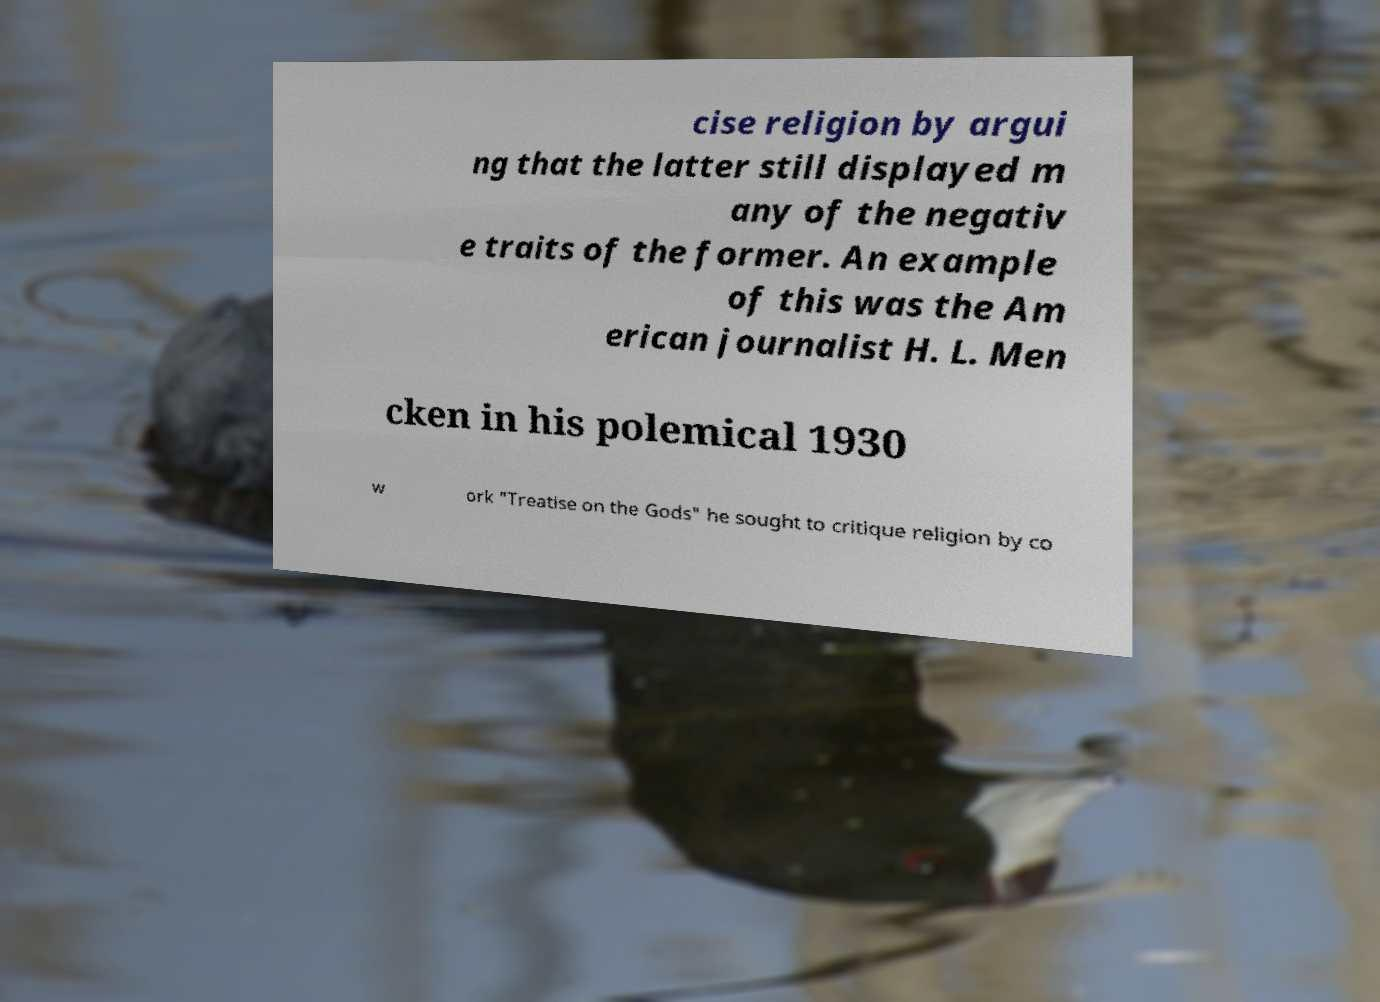Please read and relay the text visible in this image. What does it say? cise religion by argui ng that the latter still displayed m any of the negativ e traits of the former. An example of this was the Am erican journalist H. L. Men cken in his polemical 1930 w ork "Treatise on the Gods" he sought to critique religion by co 